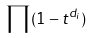<formula> <loc_0><loc_0><loc_500><loc_500>\prod ( 1 - t ^ { d _ { i } } )</formula> 